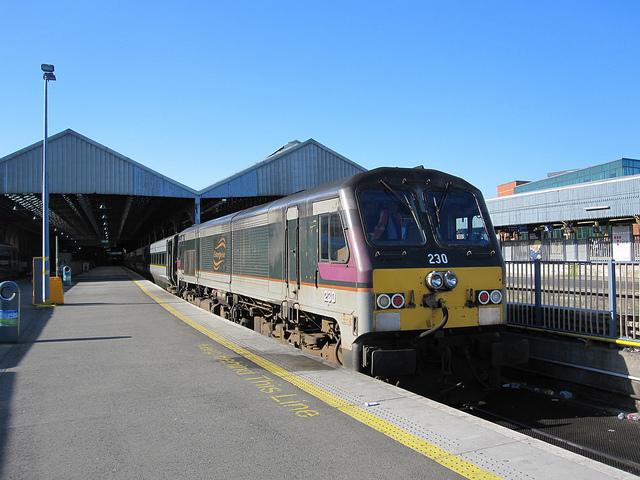What are waiting outside the train?
Keep it brief. Nothing. What color is the sky?
Answer briefly. Blue. How long is the train?
Concise answer only. Long. What number is on the train?
Concise answer only. 230. Is the sun on the left or the right of the picture?
Be succinct. Left. What color is the train?
Write a very short answer. Yellow. Where would this train be going?
Short answer required. Next stop. 